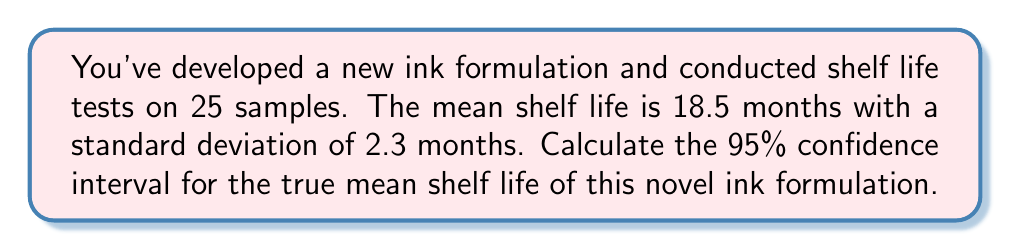Can you solve this math problem? To calculate the confidence interval, we'll follow these steps:

1) The formula for the confidence interval is:

   $$\bar{x} \pm t_{\alpha/2} \cdot \frac{s}{\sqrt{n}}$$

   where $\bar{x}$ is the sample mean, $s$ is the sample standard deviation, $n$ is the sample size, and $t_{\alpha/2}$ is the t-value for a 95% confidence level with n-1 degrees of freedom.

2) We have:
   $\bar{x} = 18.5$ months
   $s = 2.3$ months
   $n = 25$
   
3) For a 95% confidence interval with 24 degrees of freedom (n-1), the t-value is approximately 2.064.

4) Now, let's calculate the margin of error:

   $$t_{\alpha/2} \cdot \frac{s}{\sqrt{n}} = 2.064 \cdot \frac{2.3}{\sqrt{25}} = 2.064 \cdot 0.46 = 0.95$$

5) Therefore, the confidence interval is:

   $$18.5 \pm 0.95$$

6) This gives us the lower and upper bounds:
   Lower bound: $18.5 - 0.95 = 17.55$
   Upper bound: $18.5 + 0.95 = 19.45$
Answer: (17.55, 19.45) months 